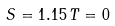<formula> <loc_0><loc_0><loc_500><loc_500>S = 1 . 1 5 \, T = 0</formula> 